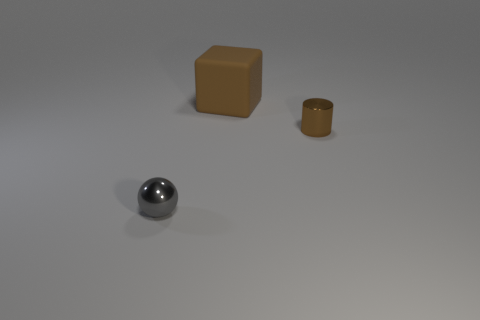Assuming these objects had to be used in a survival situation, which one would be the most useful and why? In a survival situation, the brown cylindrical container might be the most useful object. Its potential to hold liquids or store small essential items could be invaluable. The cube could also be carved or reshaped to create tools, while the reflective sphere might be used as a signaling device due to its reflective surface. 